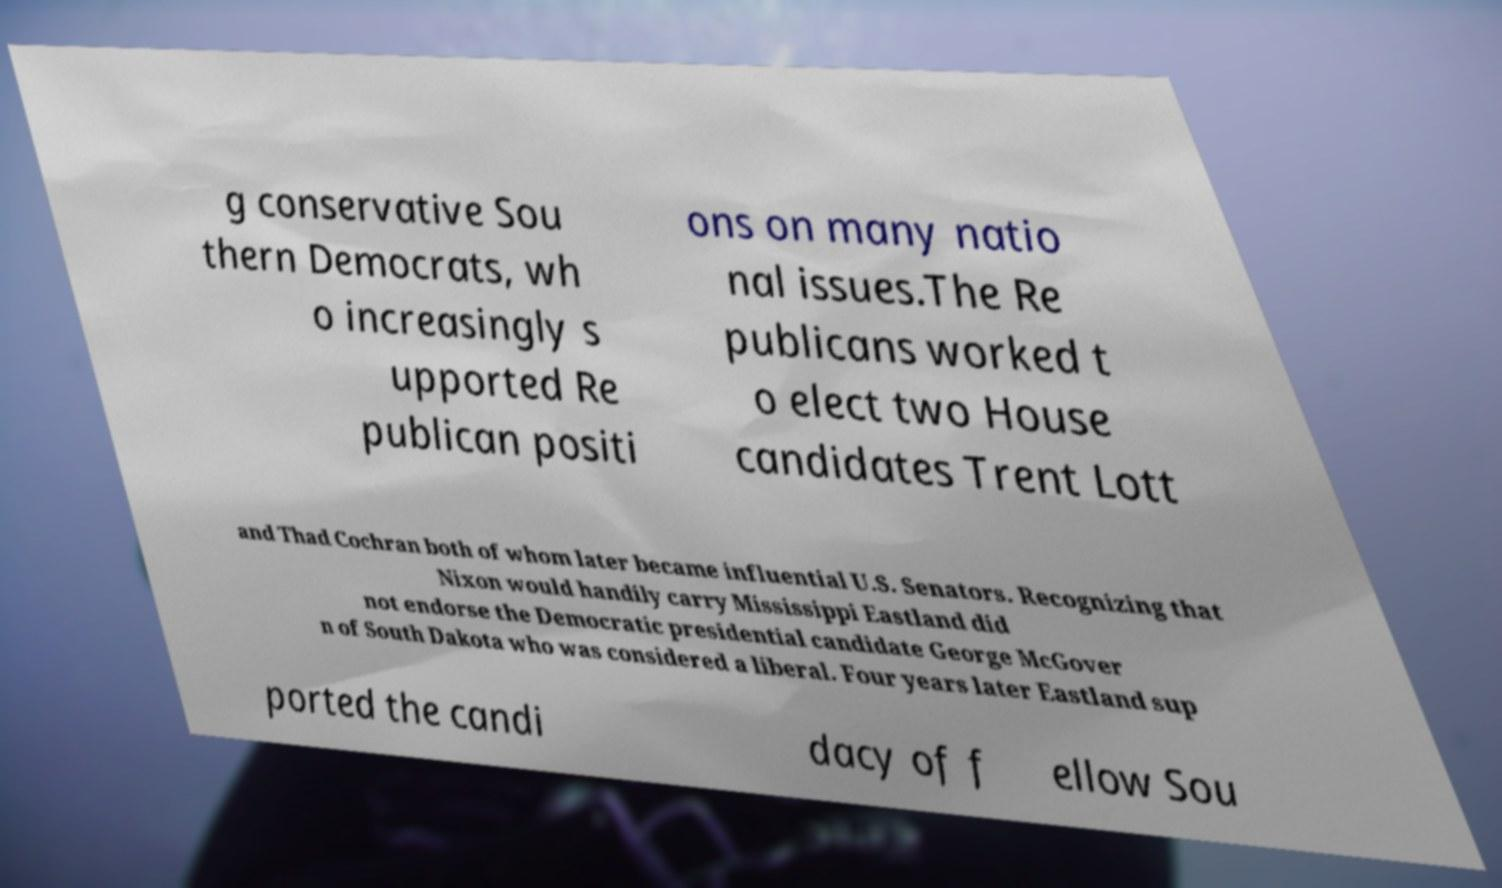Please identify and transcribe the text found in this image. g conservative Sou thern Democrats, wh o increasingly s upported Re publican positi ons on many natio nal issues.The Re publicans worked t o elect two House candidates Trent Lott and Thad Cochran both of whom later became influential U.S. Senators. Recognizing that Nixon would handily carry Mississippi Eastland did not endorse the Democratic presidential candidate George McGover n of South Dakota who was considered a liberal. Four years later Eastland sup ported the candi dacy of f ellow Sou 